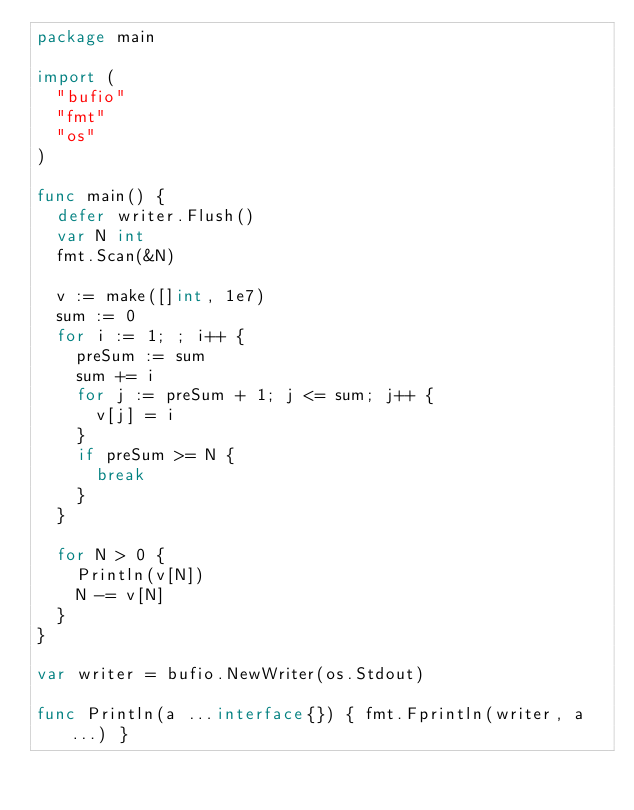<code> <loc_0><loc_0><loc_500><loc_500><_Go_>package main

import (
	"bufio"
	"fmt"
	"os"
)

func main() {
	defer writer.Flush()
	var N int
	fmt.Scan(&N)

	v := make([]int, 1e7)
	sum := 0
	for i := 1; ; i++ {
		preSum := sum
		sum += i
		for j := preSum + 1; j <= sum; j++ {
			v[j] = i
		}
		if preSum >= N {
			break
		}
	}

	for N > 0 {
		Println(v[N])
		N -= v[N]
	}
}

var writer = bufio.NewWriter(os.Stdout)

func Println(a ...interface{}) { fmt.Fprintln(writer, a...) }
</code> 